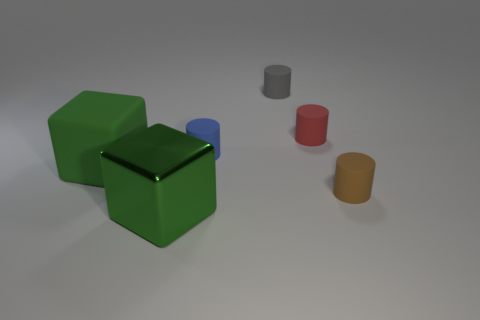There is a large green object that is behind the green shiny thing; does it have the same shape as the red thing?
Keep it short and to the point. No. Are there any red rubber cylinders?
Provide a short and direct response. Yes. There is a rubber cylinder that is in front of the small matte cylinder that is on the left side of the gray cylinder that is to the left of the tiny red matte object; what color is it?
Give a very brief answer. Brown. Are there the same number of tiny gray cylinders that are in front of the big rubber object and red things on the left side of the red object?
Offer a terse response. Yes. The red matte object that is the same size as the brown cylinder is what shape?
Give a very brief answer. Cylinder. Is there a ball that has the same color as the big metal thing?
Your answer should be compact. No. What is the shape of the tiny rubber object right of the red thing?
Ensure brevity in your answer.  Cylinder. The big metallic block has what color?
Your answer should be compact. Green. What is the color of the big object that is the same material as the small blue thing?
Your answer should be very brief. Green. What number of small cylinders have the same material as the small gray object?
Keep it short and to the point. 3. 